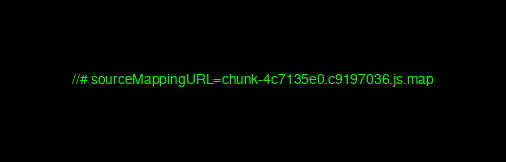Convert code to text. <code><loc_0><loc_0><loc_500><loc_500><_JavaScript_>//# sourceMappingURL=chunk-4c7135e0.c9197036.js.map</code> 